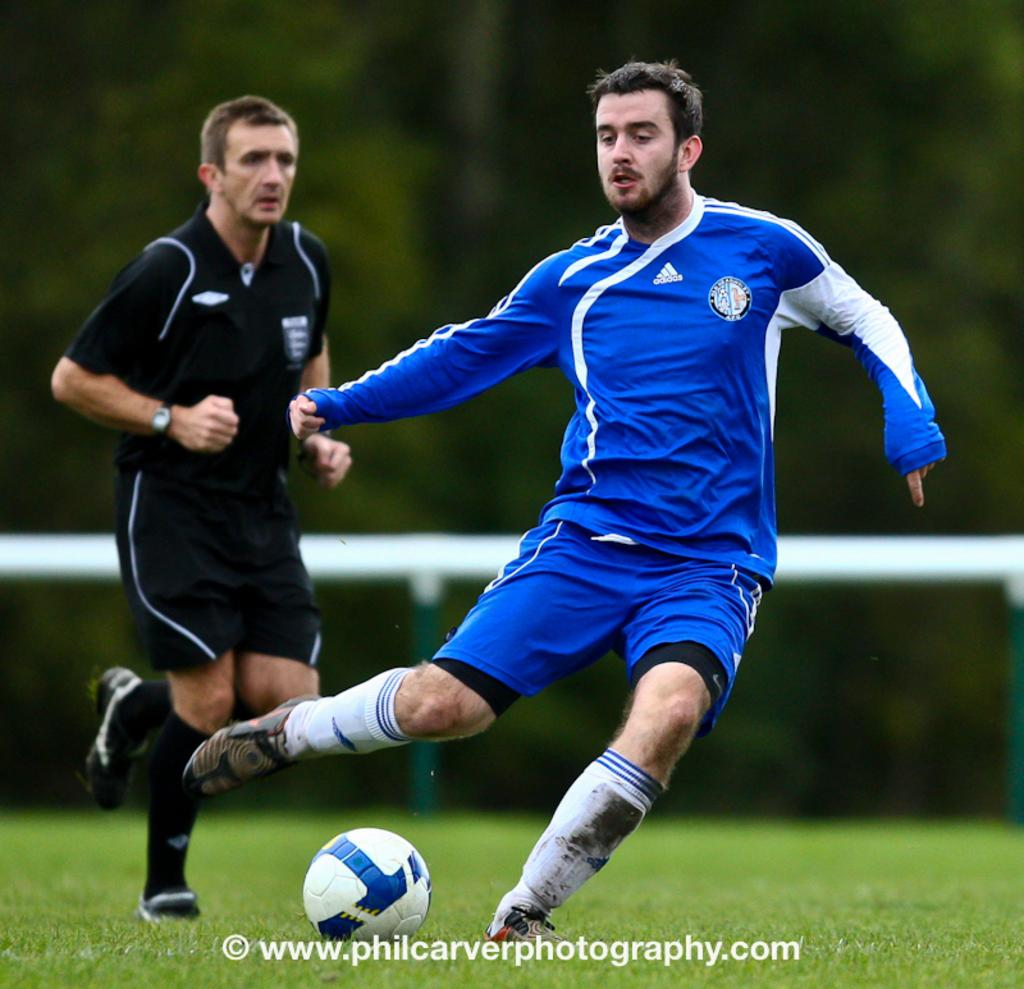How many people are in the image? There are two persons in the image. What is on the ground in the image? There is grass and a ball on the ground in the image. Can you describe the background of the image? The background appears blurry in the image. Is there any text present in the image? Yes, there is text written at the bottom of the image. What type of zipper can be seen on the ball in the image? There is no zipper present on the ball in the image. How does the grip of the field affect the movement of the persons in the image? There is no field mentioned in the image, and the persons are not shown moving. 